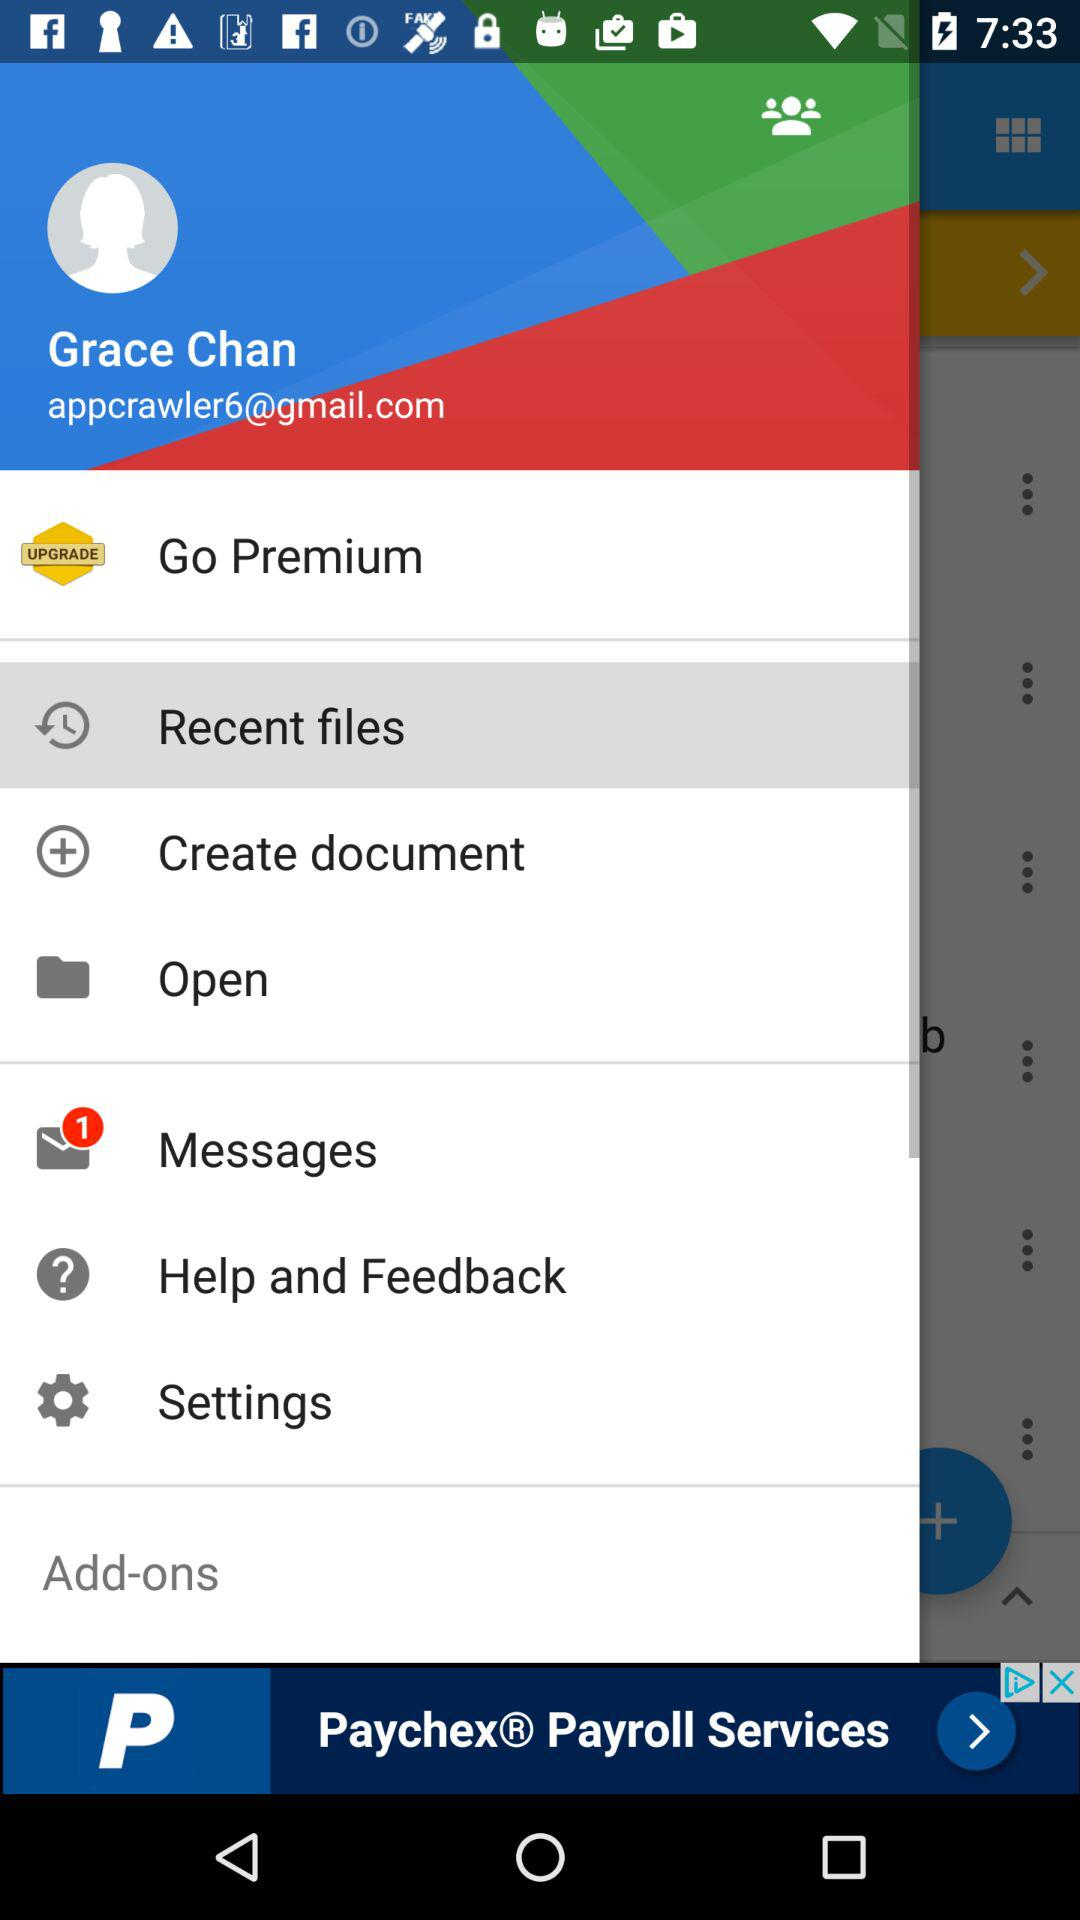What is the name of the user? The name of the user is Grace Chan. 